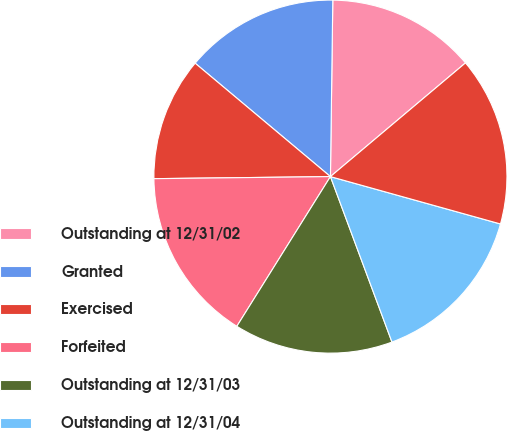Convert chart to OTSL. <chart><loc_0><loc_0><loc_500><loc_500><pie_chart><fcel>Outstanding at 12/31/02<fcel>Granted<fcel>Exercised<fcel>Forfeited<fcel>Outstanding at 12/31/03<fcel>Outstanding at 12/31/04<fcel>Outstanding at 12/31/05<nl><fcel>13.65%<fcel>14.11%<fcel>11.29%<fcel>15.92%<fcel>14.56%<fcel>15.01%<fcel>15.46%<nl></chart> 